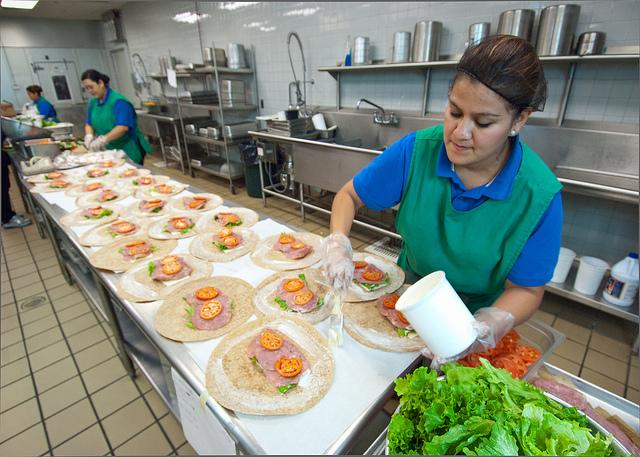Why would someone eat this?
Give a very brief answer. Hungry. What does the woman have on her hands?
Give a very brief answer. Gloves. Why does she wear gloves and a hairnet?
Answer briefly. Working with food. 